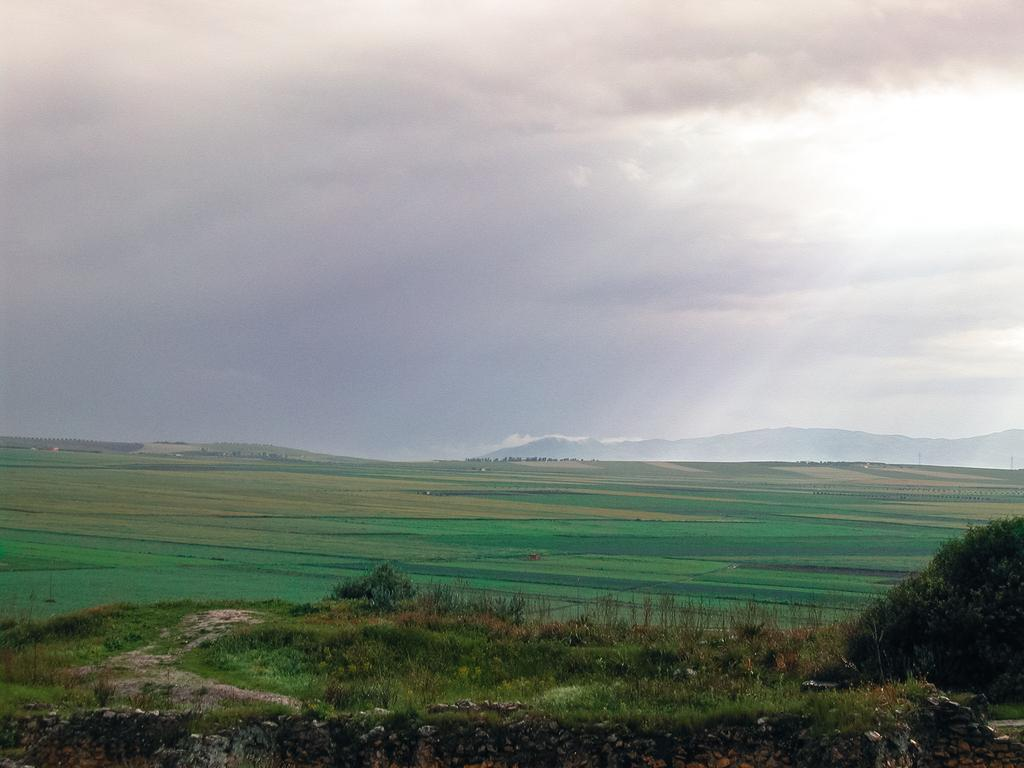What type of vegetation is visible in the front of the image? There is grass and a plant in the front of the image. What can be seen in the background of the image? There are hills in the background of the image. What is visible at the top of the image? The sky is visible at the top of the image. What can be observed in the sky? Clouds are present in the sky. What letters are visible on the hills in the image? There are no letters visible on the hills in the image; only grass, a plant, hills, and clouds are present. Can you see a town in the image? There is no town visible in the image; it features grass, a plant, hills, and clouds. 